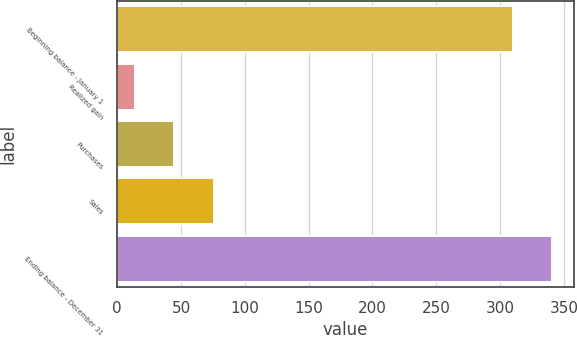Convert chart to OTSL. <chart><loc_0><loc_0><loc_500><loc_500><bar_chart><fcel>Beginning balance - January 1<fcel>Realized gain<fcel>Purchases<fcel>Sales<fcel>Ending balance - December 31<nl><fcel>310<fcel>14<fcel>44.8<fcel>75.6<fcel>340.8<nl></chart> 